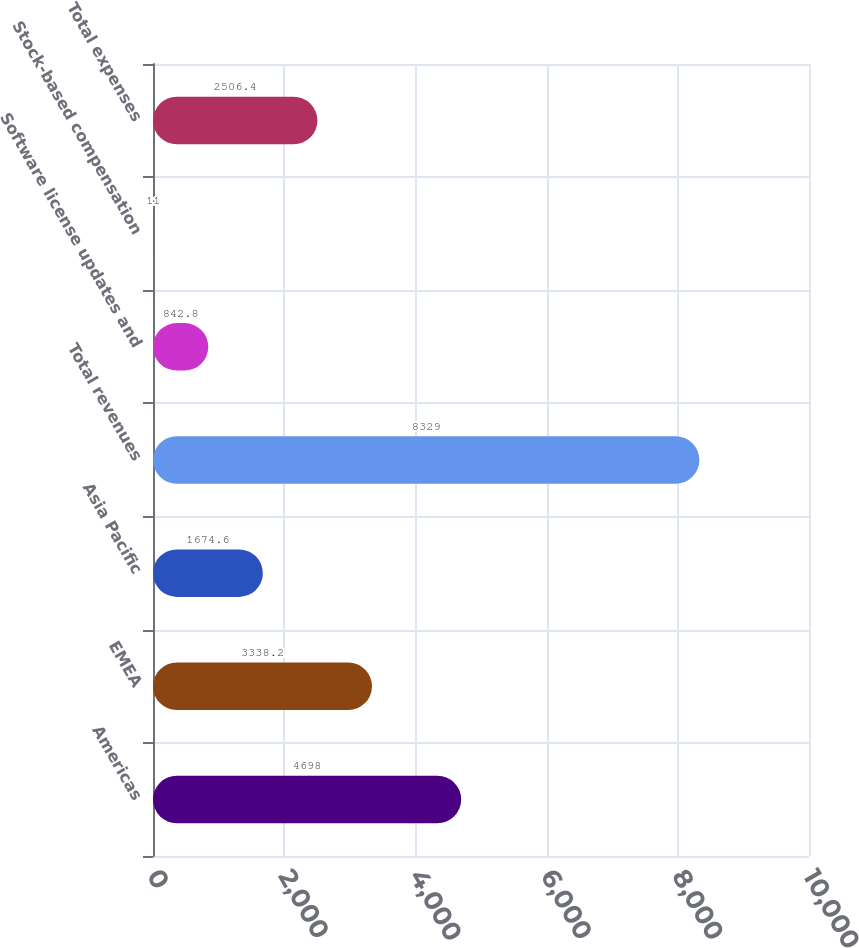Convert chart. <chart><loc_0><loc_0><loc_500><loc_500><bar_chart><fcel>Americas<fcel>EMEA<fcel>Asia Pacific<fcel>Total revenues<fcel>Software license updates and<fcel>Stock-based compensation<fcel>Total expenses<nl><fcel>4698<fcel>3338.2<fcel>1674.6<fcel>8329<fcel>842.8<fcel>11<fcel>2506.4<nl></chart> 